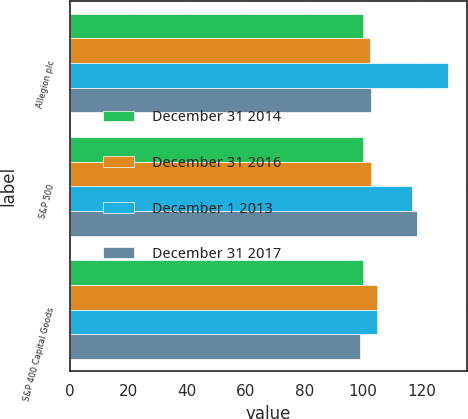Convert chart. <chart><loc_0><loc_0><loc_500><loc_500><stacked_bar_chart><ecel><fcel>Allegion plc<fcel>S&P 500<fcel>S&P 400 Capital Goods<nl><fcel>December 31 2014<fcel>100<fcel>100<fcel>100<nl><fcel>December 31 2016<fcel>102.2<fcel>102.53<fcel>104.58<nl><fcel>December 1 2013<fcel>129.03<fcel>116.57<fcel>104.84<nl><fcel>December 31 2017<fcel>102.53<fcel>118.18<fcel>99.07<nl></chart> 